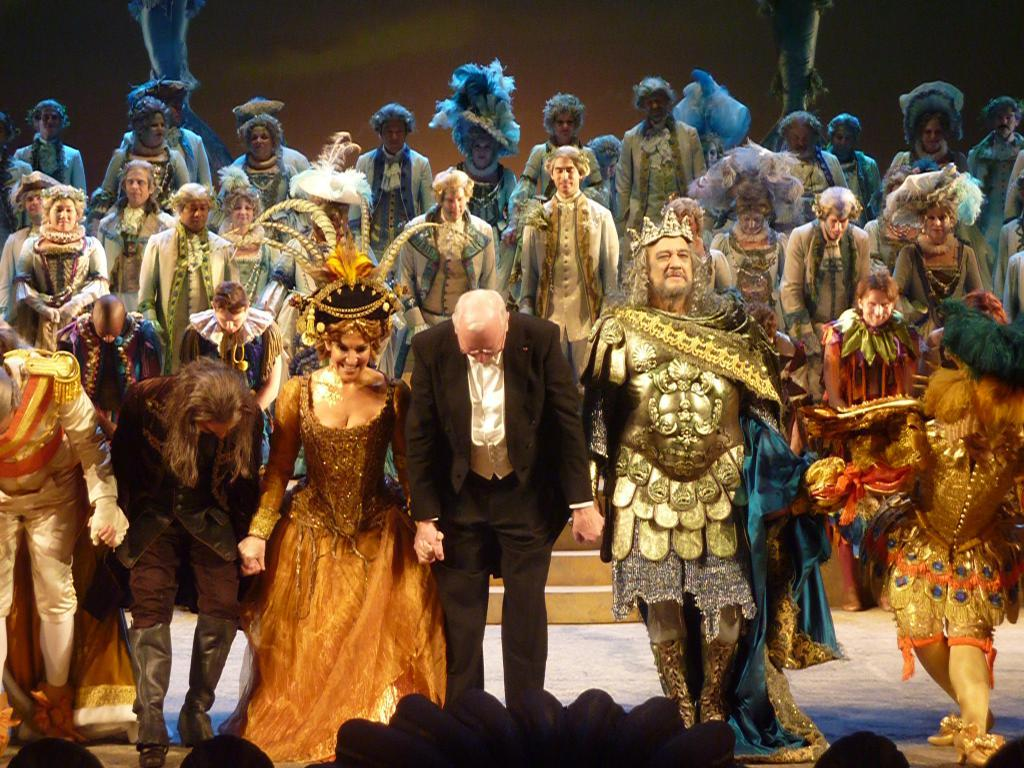What are the persons in the image wearing? The persons in the image are wearing fancy dress. Can you describe the attire of one specific person in the image? There is a person wearing a black suit in the image. How is the person wearing a black suit positioned in relation to the others? The person wearing a black suit is standing between the others. What type of bone can be seen in the image? There is no bone present in the image. How does the flock of birds interact with the persons in the image? There are no birds, let alone a flock of them, present in the image. 